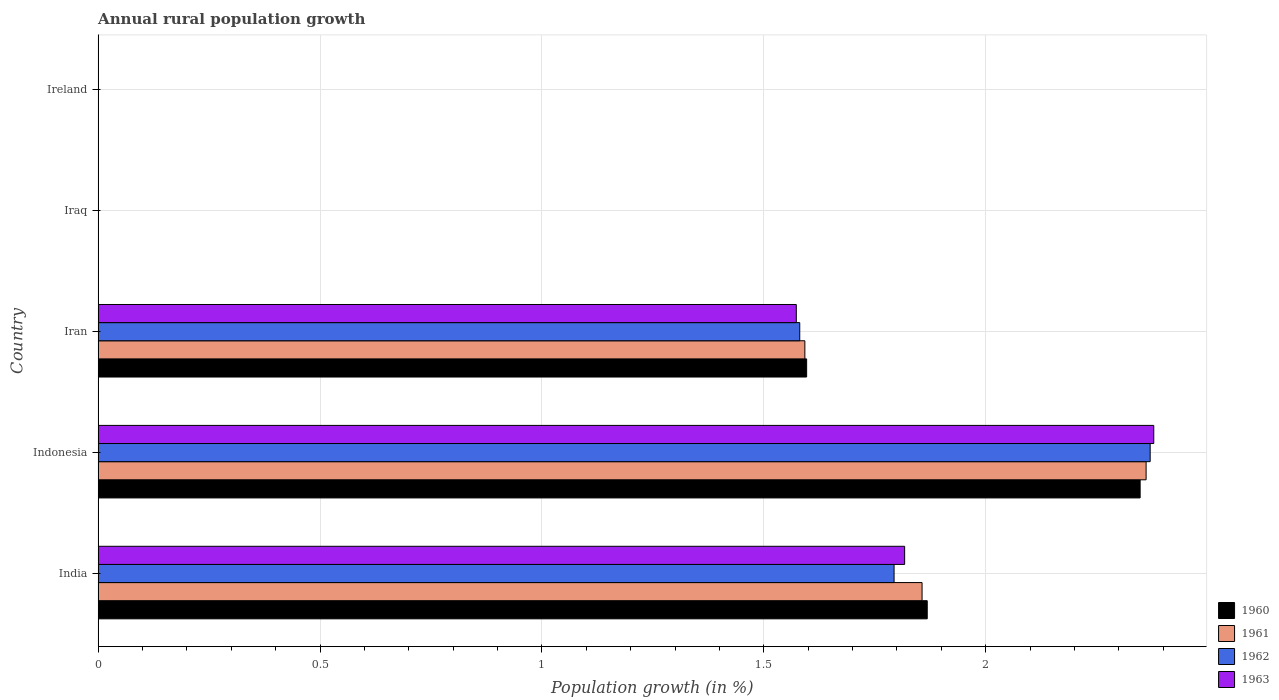Are the number of bars per tick equal to the number of legend labels?
Offer a terse response. No. Are the number of bars on each tick of the Y-axis equal?
Your answer should be compact. No. How many bars are there on the 5th tick from the bottom?
Your answer should be very brief. 0. What is the label of the 2nd group of bars from the top?
Offer a terse response. Iraq. In how many cases, is the number of bars for a given country not equal to the number of legend labels?
Provide a short and direct response. 2. What is the percentage of rural population growth in 1963 in India?
Make the answer very short. 1.82. Across all countries, what is the maximum percentage of rural population growth in 1960?
Offer a very short reply. 2.35. In which country was the percentage of rural population growth in 1960 maximum?
Your answer should be very brief. Indonesia. What is the total percentage of rural population growth in 1962 in the graph?
Your answer should be very brief. 5.74. What is the difference between the percentage of rural population growth in 1962 in India and that in Iran?
Your answer should be compact. 0.21. What is the average percentage of rural population growth in 1962 per country?
Keep it short and to the point. 1.15. What is the difference between the percentage of rural population growth in 1963 and percentage of rural population growth in 1961 in India?
Ensure brevity in your answer.  -0.04. In how many countries, is the percentage of rural population growth in 1962 greater than 0.30000000000000004 %?
Keep it short and to the point. 3. What is the ratio of the percentage of rural population growth in 1962 in Indonesia to that in Iran?
Provide a succinct answer. 1.5. What is the difference between the highest and the second highest percentage of rural population growth in 1960?
Your answer should be compact. 0.48. What is the difference between the highest and the lowest percentage of rural population growth in 1963?
Give a very brief answer. 2.38. In how many countries, is the percentage of rural population growth in 1963 greater than the average percentage of rural population growth in 1963 taken over all countries?
Provide a succinct answer. 3. Is it the case that in every country, the sum of the percentage of rural population growth in 1961 and percentage of rural population growth in 1963 is greater than the sum of percentage of rural population growth in 1960 and percentage of rural population growth in 1962?
Offer a very short reply. No. How many bars are there?
Keep it short and to the point. 12. Are all the bars in the graph horizontal?
Make the answer very short. Yes. What is the difference between two consecutive major ticks on the X-axis?
Provide a succinct answer. 0.5. Are the values on the major ticks of X-axis written in scientific E-notation?
Provide a succinct answer. No. Where does the legend appear in the graph?
Keep it short and to the point. Bottom right. How many legend labels are there?
Give a very brief answer. 4. How are the legend labels stacked?
Your answer should be very brief. Vertical. What is the title of the graph?
Give a very brief answer. Annual rural population growth. Does "1988" appear as one of the legend labels in the graph?
Your answer should be compact. No. What is the label or title of the X-axis?
Ensure brevity in your answer.  Population growth (in %). What is the Population growth (in %) in 1960 in India?
Offer a terse response. 1.87. What is the Population growth (in %) of 1961 in India?
Your answer should be compact. 1.86. What is the Population growth (in %) of 1962 in India?
Keep it short and to the point. 1.79. What is the Population growth (in %) of 1963 in India?
Ensure brevity in your answer.  1.82. What is the Population growth (in %) of 1960 in Indonesia?
Your answer should be very brief. 2.35. What is the Population growth (in %) in 1961 in Indonesia?
Provide a short and direct response. 2.36. What is the Population growth (in %) in 1962 in Indonesia?
Your answer should be very brief. 2.37. What is the Population growth (in %) of 1963 in Indonesia?
Ensure brevity in your answer.  2.38. What is the Population growth (in %) in 1960 in Iran?
Keep it short and to the point. 1.6. What is the Population growth (in %) in 1961 in Iran?
Your answer should be very brief. 1.59. What is the Population growth (in %) in 1962 in Iran?
Your answer should be very brief. 1.58. What is the Population growth (in %) in 1963 in Iran?
Offer a very short reply. 1.57. What is the Population growth (in %) in 1963 in Iraq?
Provide a succinct answer. 0. What is the Population growth (in %) in 1961 in Ireland?
Make the answer very short. 0. What is the Population growth (in %) of 1963 in Ireland?
Your answer should be very brief. 0. Across all countries, what is the maximum Population growth (in %) in 1960?
Keep it short and to the point. 2.35. Across all countries, what is the maximum Population growth (in %) of 1961?
Your answer should be compact. 2.36. Across all countries, what is the maximum Population growth (in %) of 1962?
Offer a very short reply. 2.37. Across all countries, what is the maximum Population growth (in %) in 1963?
Your response must be concise. 2.38. Across all countries, what is the minimum Population growth (in %) of 1960?
Your answer should be compact. 0. Across all countries, what is the minimum Population growth (in %) in 1962?
Your answer should be compact. 0. Across all countries, what is the minimum Population growth (in %) of 1963?
Your answer should be very brief. 0. What is the total Population growth (in %) in 1960 in the graph?
Offer a terse response. 5.81. What is the total Population growth (in %) in 1961 in the graph?
Offer a terse response. 5.81. What is the total Population growth (in %) in 1962 in the graph?
Give a very brief answer. 5.74. What is the total Population growth (in %) in 1963 in the graph?
Your answer should be compact. 5.77. What is the difference between the Population growth (in %) in 1960 in India and that in Indonesia?
Your response must be concise. -0.48. What is the difference between the Population growth (in %) in 1961 in India and that in Indonesia?
Provide a short and direct response. -0.5. What is the difference between the Population growth (in %) of 1962 in India and that in Indonesia?
Ensure brevity in your answer.  -0.58. What is the difference between the Population growth (in %) in 1963 in India and that in Indonesia?
Give a very brief answer. -0.56. What is the difference between the Population growth (in %) of 1960 in India and that in Iran?
Offer a terse response. 0.27. What is the difference between the Population growth (in %) of 1961 in India and that in Iran?
Your answer should be compact. 0.26. What is the difference between the Population growth (in %) in 1962 in India and that in Iran?
Your answer should be compact. 0.21. What is the difference between the Population growth (in %) of 1963 in India and that in Iran?
Give a very brief answer. 0.24. What is the difference between the Population growth (in %) of 1960 in Indonesia and that in Iran?
Keep it short and to the point. 0.75. What is the difference between the Population growth (in %) in 1961 in Indonesia and that in Iran?
Offer a terse response. 0.77. What is the difference between the Population growth (in %) in 1962 in Indonesia and that in Iran?
Your answer should be very brief. 0.79. What is the difference between the Population growth (in %) in 1963 in Indonesia and that in Iran?
Make the answer very short. 0.81. What is the difference between the Population growth (in %) in 1960 in India and the Population growth (in %) in 1961 in Indonesia?
Provide a succinct answer. -0.49. What is the difference between the Population growth (in %) in 1960 in India and the Population growth (in %) in 1962 in Indonesia?
Provide a succinct answer. -0.5. What is the difference between the Population growth (in %) in 1960 in India and the Population growth (in %) in 1963 in Indonesia?
Keep it short and to the point. -0.51. What is the difference between the Population growth (in %) in 1961 in India and the Population growth (in %) in 1962 in Indonesia?
Offer a very short reply. -0.51. What is the difference between the Population growth (in %) of 1961 in India and the Population growth (in %) of 1963 in Indonesia?
Provide a succinct answer. -0.52. What is the difference between the Population growth (in %) in 1962 in India and the Population growth (in %) in 1963 in Indonesia?
Your answer should be very brief. -0.59. What is the difference between the Population growth (in %) in 1960 in India and the Population growth (in %) in 1961 in Iran?
Offer a terse response. 0.28. What is the difference between the Population growth (in %) of 1960 in India and the Population growth (in %) of 1962 in Iran?
Offer a very short reply. 0.29. What is the difference between the Population growth (in %) in 1960 in India and the Population growth (in %) in 1963 in Iran?
Provide a succinct answer. 0.29. What is the difference between the Population growth (in %) of 1961 in India and the Population growth (in %) of 1962 in Iran?
Ensure brevity in your answer.  0.28. What is the difference between the Population growth (in %) in 1961 in India and the Population growth (in %) in 1963 in Iran?
Make the answer very short. 0.28. What is the difference between the Population growth (in %) of 1962 in India and the Population growth (in %) of 1963 in Iran?
Keep it short and to the point. 0.22. What is the difference between the Population growth (in %) in 1960 in Indonesia and the Population growth (in %) in 1961 in Iran?
Your answer should be compact. 0.76. What is the difference between the Population growth (in %) in 1960 in Indonesia and the Population growth (in %) in 1962 in Iran?
Provide a short and direct response. 0.77. What is the difference between the Population growth (in %) of 1960 in Indonesia and the Population growth (in %) of 1963 in Iran?
Give a very brief answer. 0.77. What is the difference between the Population growth (in %) in 1961 in Indonesia and the Population growth (in %) in 1962 in Iran?
Keep it short and to the point. 0.78. What is the difference between the Population growth (in %) in 1961 in Indonesia and the Population growth (in %) in 1963 in Iran?
Ensure brevity in your answer.  0.79. What is the difference between the Population growth (in %) in 1962 in Indonesia and the Population growth (in %) in 1963 in Iran?
Your answer should be compact. 0.8. What is the average Population growth (in %) of 1960 per country?
Offer a very short reply. 1.16. What is the average Population growth (in %) in 1961 per country?
Give a very brief answer. 1.16. What is the average Population growth (in %) in 1962 per country?
Keep it short and to the point. 1.15. What is the average Population growth (in %) of 1963 per country?
Ensure brevity in your answer.  1.15. What is the difference between the Population growth (in %) in 1960 and Population growth (in %) in 1961 in India?
Keep it short and to the point. 0.01. What is the difference between the Population growth (in %) in 1960 and Population growth (in %) in 1962 in India?
Ensure brevity in your answer.  0.07. What is the difference between the Population growth (in %) in 1960 and Population growth (in %) in 1963 in India?
Offer a terse response. 0.05. What is the difference between the Population growth (in %) of 1961 and Population growth (in %) of 1962 in India?
Your answer should be very brief. 0.06. What is the difference between the Population growth (in %) in 1961 and Population growth (in %) in 1963 in India?
Ensure brevity in your answer.  0.04. What is the difference between the Population growth (in %) in 1962 and Population growth (in %) in 1963 in India?
Give a very brief answer. -0.02. What is the difference between the Population growth (in %) of 1960 and Population growth (in %) of 1961 in Indonesia?
Offer a very short reply. -0.01. What is the difference between the Population growth (in %) in 1960 and Population growth (in %) in 1962 in Indonesia?
Offer a very short reply. -0.02. What is the difference between the Population growth (in %) in 1960 and Population growth (in %) in 1963 in Indonesia?
Your answer should be very brief. -0.03. What is the difference between the Population growth (in %) of 1961 and Population growth (in %) of 1962 in Indonesia?
Offer a very short reply. -0.01. What is the difference between the Population growth (in %) of 1961 and Population growth (in %) of 1963 in Indonesia?
Offer a terse response. -0.02. What is the difference between the Population growth (in %) of 1962 and Population growth (in %) of 1963 in Indonesia?
Offer a very short reply. -0.01. What is the difference between the Population growth (in %) in 1960 and Population growth (in %) in 1961 in Iran?
Your answer should be very brief. 0. What is the difference between the Population growth (in %) of 1960 and Population growth (in %) of 1962 in Iran?
Your answer should be very brief. 0.02. What is the difference between the Population growth (in %) in 1960 and Population growth (in %) in 1963 in Iran?
Offer a very short reply. 0.02. What is the difference between the Population growth (in %) of 1961 and Population growth (in %) of 1962 in Iran?
Give a very brief answer. 0.01. What is the difference between the Population growth (in %) of 1961 and Population growth (in %) of 1963 in Iran?
Your response must be concise. 0.02. What is the difference between the Population growth (in %) of 1962 and Population growth (in %) of 1963 in Iran?
Your response must be concise. 0.01. What is the ratio of the Population growth (in %) of 1960 in India to that in Indonesia?
Your response must be concise. 0.8. What is the ratio of the Population growth (in %) of 1961 in India to that in Indonesia?
Your answer should be compact. 0.79. What is the ratio of the Population growth (in %) in 1962 in India to that in Indonesia?
Your response must be concise. 0.76. What is the ratio of the Population growth (in %) in 1963 in India to that in Indonesia?
Your answer should be compact. 0.76. What is the ratio of the Population growth (in %) in 1960 in India to that in Iran?
Your answer should be very brief. 1.17. What is the ratio of the Population growth (in %) in 1961 in India to that in Iran?
Provide a succinct answer. 1.17. What is the ratio of the Population growth (in %) of 1962 in India to that in Iran?
Your answer should be compact. 1.13. What is the ratio of the Population growth (in %) of 1963 in India to that in Iran?
Keep it short and to the point. 1.16. What is the ratio of the Population growth (in %) of 1960 in Indonesia to that in Iran?
Offer a terse response. 1.47. What is the ratio of the Population growth (in %) in 1961 in Indonesia to that in Iran?
Your response must be concise. 1.48. What is the ratio of the Population growth (in %) in 1962 in Indonesia to that in Iran?
Give a very brief answer. 1.5. What is the ratio of the Population growth (in %) in 1963 in Indonesia to that in Iran?
Your response must be concise. 1.51. What is the difference between the highest and the second highest Population growth (in %) of 1960?
Provide a succinct answer. 0.48. What is the difference between the highest and the second highest Population growth (in %) of 1961?
Offer a very short reply. 0.5. What is the difference between the highest and the second highest Population growth (in %) in 1962?
Your answer should be very brief. 0.58. What is the difference between the highest and the second highest Population growth (in %) in 1963?
Provide a succinct answer. 0.56. What is the difference between the highest and the lowest Population growth (in %) in 1960?
Offer a terse response. 2.35. What is the difference between the highest and the lowest Population growth (in %) of 1961?
Make the answer very short. 2.36. What is the difference between the highest and the lowest Population growth (in %) of 1962?
Your answer should be compact. 2.37. What is the difference between the highest and the lowest Population growth (in %) in 1963?
Give a very brief answer. 2.38. 